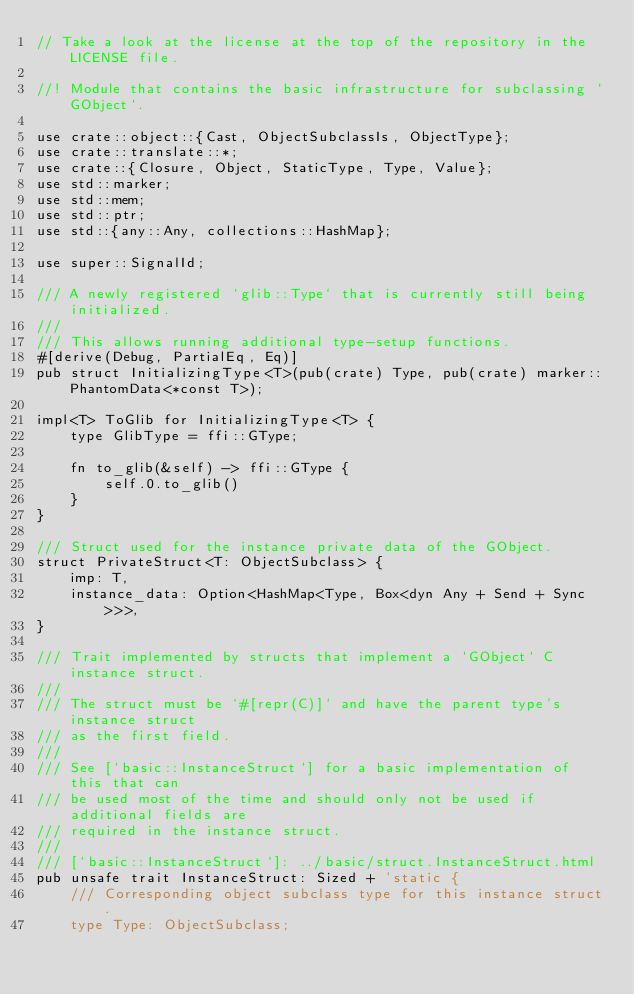Convert code to text. <code><loc_0><loc_0><loc_500><loc_500><_Rust_>// Take a look at the license at the top of the repository in the LICENSE file.

//! Module that contains the basic infrastructure for subclassing `GObject`.

use crate::object::{Cast, ObjectSubclassIs, ObjectType};
use crate::translate::*;
use crate::{Closure, Object, StaticType, Type, Value};
use std::marker;
use std::mem;
use std::ptr;
use std::{any::Any, collections::HashMap};

use super::SignalId;

/// A newly registered `glib::Type` that is currently still being initialized.
///
/// This allows running additional type-setup functions.
#[derive(Debug, PartialEq, Eq)]
pub struct InitializingType<T>(pub(crate) Type, pub(crate) marker::PhantomData<*const T>);

impl<T> ToGlib for InitializingType<T> {
    type GlibType = ffi::GType;

    fn to_glib(&self) -> ffi::GType {
        self.0.to_glib()
    }
}

/// Struct used for the instance private data of the GObject.
struct PrivateStruct<T: ObjectSubclass> {
    imp: T,
    instance_data: Option<HashMap<Type, Box<dyn Any + Send + Sync>>>,
}

/// Trait implemented by structs that implement a `GObject` C instance struct.
///
/// The struct must be `#[repr(C)]` and have the parent type's instance struct
/// as the first field.
///
/// See [`basic::InstanceStruct`] for a basic implementation of this that can
/// be used most of the time and should only not be used if additional fields are
/// required in the instance struct.
///
/// [`basic::InstanceStruct`]: ../basic/struct.InstanceStruct.html
pub unsafe trait InstanceStruct: Sized + 'static {
    /// Corresponding object subclass type for this instance struct.
    type Type: ObjectSubclass;
</code> 